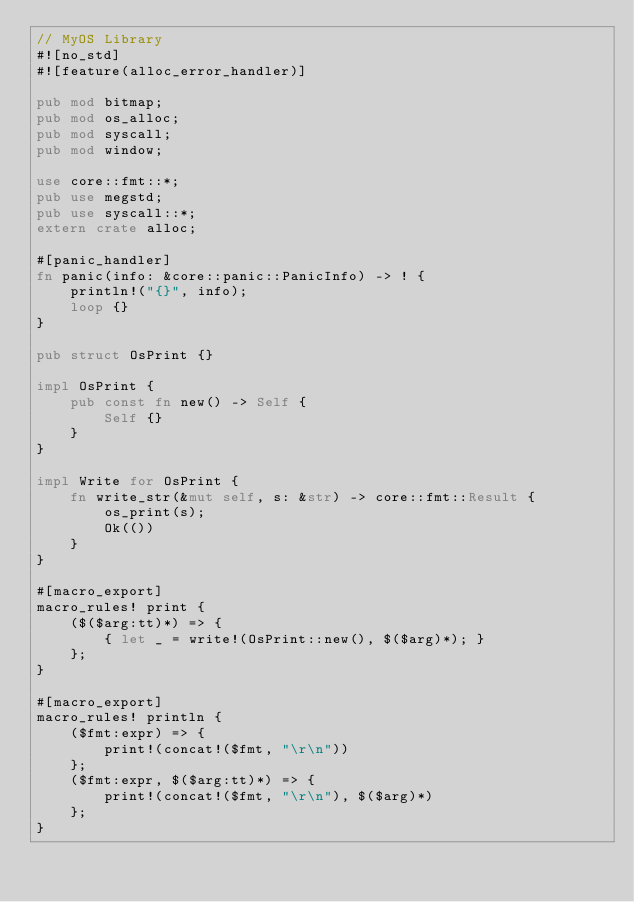<code> <loc_0><loc_0><loc_500><loc_500><_Rust_>// MyOS Library
#![no_std]
#![feature(alloc_error_handler)]

pub mod bitmap;
pub mod os_alloc;
pub mod syscall;
pub mod window;

use core::fmt::*;
pub use megstd;
pub use syscall::*;
extern crate alloc;

#[panic_handler]
fn panic(info: &core::panic::PanicInfo) -> ! {
    println!("{}", info);
    loop {}
}

pub struct OsPrint {}

impl OsPrint {
    pub const fn new() -> Self {
        Self {}
    }
}

impl Write for OsPrint {
    fn write_str(&mut self, s: &str) -> core::fmt::Result {
        os_print(s);
        Ok(())
    }
}

#[macro_export]
macro_rules! print {
    ($($arg:tt)*) => {
        { let _ = write!(OsPrint::new(), $($arg)*); }
    };
}

#[macro_export]
macro_rules! println {
    ($fmt:expr) => {
        print!(concat!($fmt, "\r\n"))
    };
    ($fmt:expr, $($arg:tt)*) => {
        print!(concat!($fmt, "\r\n"), $($arg)*)
    };
}
</code> 